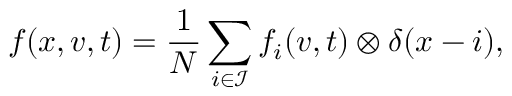<formula> <loc_0><loc_0><loc_500><loc_500>f ( x , v , t ) = \frac { 1 } { N } \sum _ { i \in \mathcal { I } } f _ { i } ( v , t ) \otimes \delta ( x - i ) ,</formula> 